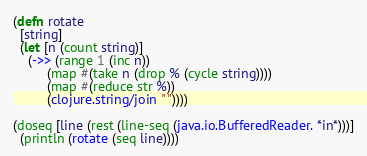<code> <loc_0><loc_0><loc_500><loc_500><_Clojure_>(defn rotate
  [string]
  (let [n (count string)]
    (->> (range 1 (inc n))
         (map #(take n (drop % (cycle string))))
         (map #(reduce str %))
         (clojure.string/join " "))))

(doseq [line (rest (line-seq (java.io.BufferedReader. *in*)))]
  (println (rotate (seq line))))
</code> 